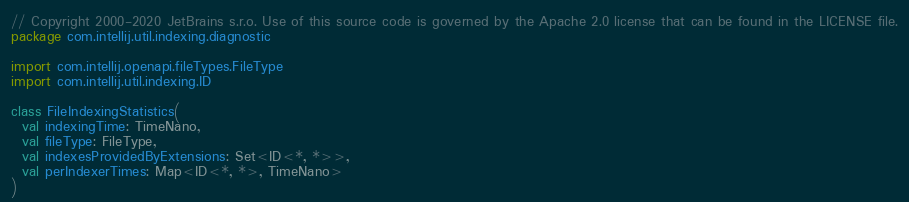<code> <loc_0><loc_0><loc_500><loc_500><_Kotlin_>// Copyright 2000-2020 JetBrains s.r.o. Use of this source code is governed by the Apache 2.0 license that can be found in the LICENSE file.
package com.intellij.util.indexing.diagnostic

import com.intellij.openapi.fileTypes.FileType
import com.intellij.util.indexing.ID

class FileIndexingStatistics(
  val indexingTime: TimeNano,
  val fileType: FileType,
  val indexesProvidedByExtensions: Set<ID<*, *>>,
  val perIndexerTimes: Map<ID<*, *>, TimeNano>
) </code> 